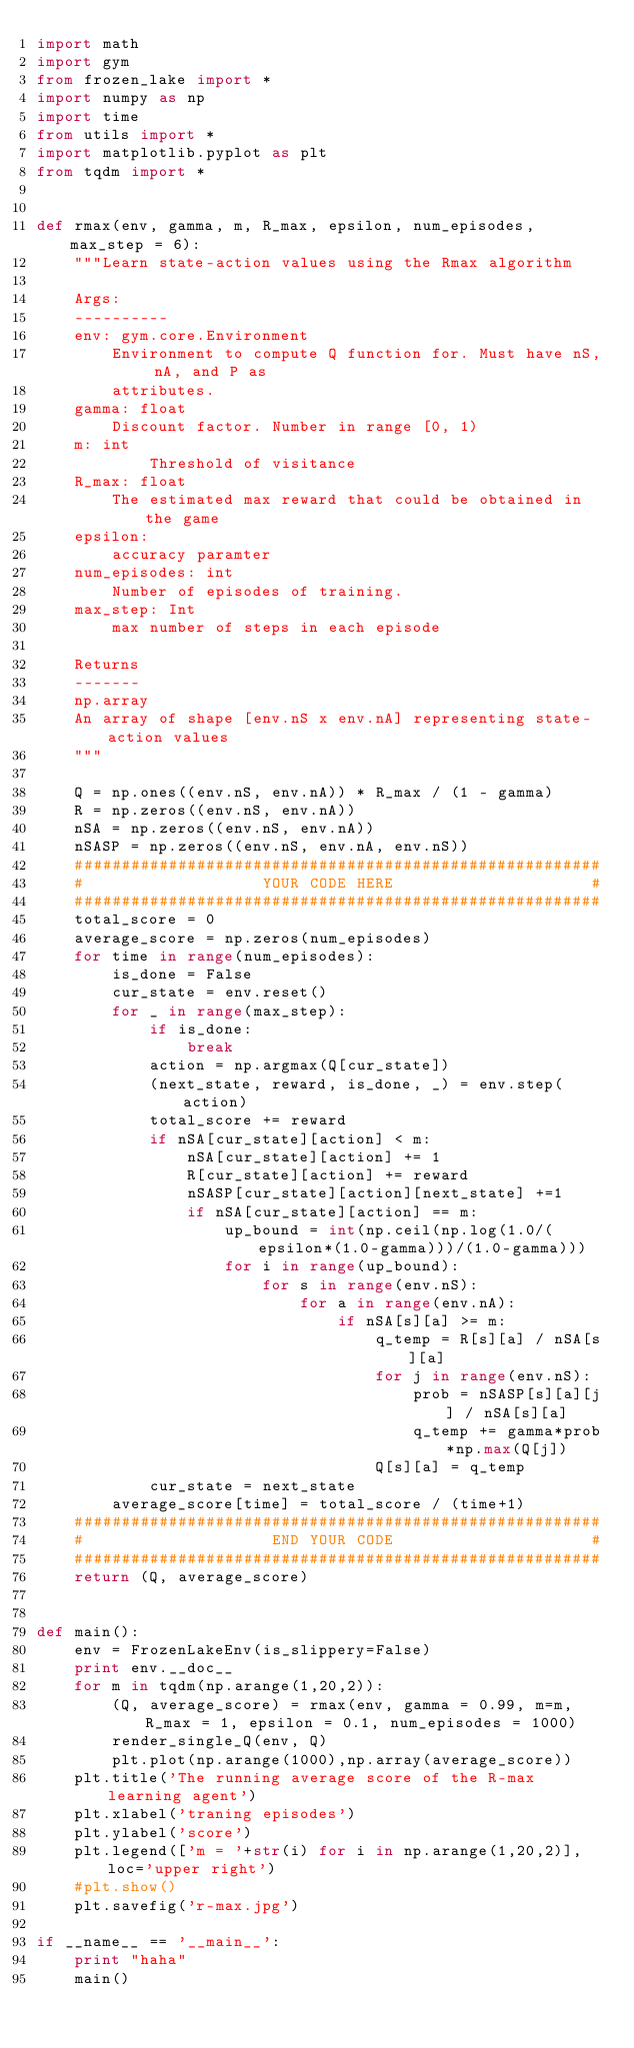<code> <loc_0><loc_0><loc_500><loc_500><_Python_>import math
import gym
from frozen_lake import *
import numpy as np
import time
from utils import *
import matplotlib.pyplot as plt
from tqdm import *


def rmax(env, gamma, m, R_max, epsilon, num_episodes, max_step = 6):
    """Learn state-action values using the Rmax algorithm

    Args:
    ----------
    env: gym.core.Environment
        Environment to compute Q function for. Must have nS, nA, and P as
        attributes.
    gamma: float
        Discount factor. Number in range [0, 1)
    m: int
        	Threshold of visitance
    R_max: float 
        The estimated max reward that could be obtained in the game
    epsilon: 
        accuracy paramter
    num_episodes: int 
        Number of episodes of training.
    max_step: Int
        max number of steps in each episode

    Returns
    -------
    np.array
    An array of shape [env.nS x env.nA] representing state-action values
    """

    Q = np.ones((env.nS, env.nA)) * R_max / (1 - gamma)
    R = np.zeros((env.nS, env.nA))
    nSA = np.zeros((env.nS, env.nA))
    nSASP = np.zeros((env.nS, env.nA, env.nS))
    ########################################################
    #                   YOUR CODE HERE                     #
    ########################################################
    total_score = 0
    average_score = np.zeros(num_episodes)
    for time in range(num_episodes):
        is_done = False
        cur_state = env.reset()
        for _ in range(max_step):
            if is_done:
                break
            action = np.argmax(Q[cur_state])
            (next_state, reward, is_done, _) = env.step(action)
            total_score += reward
            if nSA[cur_state][action] < m:
                nSA[cur_state][action] += 1
                R[cur_state][action] += reward
                nSASP[cur_state][action][next_state] +=1
                if nSA[cur_state][action] == m:
                    up_bound = int(np.ceil(np.log(1.0/(epsilon*(1.0-gamma)))/(1.0-gamma)))
                    for i in range(up_bound):
                        for s in range(env.nS):
                            for a in range(env.nA):
                                if nSA[s][a] >= m:
                                    q_temp = R[s][a] / nSA[s][a]
                                    for j in range(env.nS):
                                        prob = nSASP[s][a][j] / nSA[s][a]    
                                        q_temp += gamma*prob*np.max(Q[j])
                                    Q[s][a] = q_temp
            cur_state = next_state
        average_score[time] = total_score / (time+1)
    ########################################################
    #                    END YOUR CODE                     #
    ########################################################
    return (Q, average_score)


def main():
    env = FrozenLakeEnv(is_slippery=False)
    print env.__doc__
    for m in tqdm(np.arange(1,20,2)):
        (Q, average_score) = rmax(env, gamma = 0.99, m=m, R_max = 1, epsilon = 0.1, num_episodes = 1000)
        render_single_Q(env, Q)
        plt.plot(np.arange(1000),np.array(average_score))
    plt.title('The running average score of the R-max learning agent')
    plt.xlabel('traning episodes')
    plt.ylabel('score')
    plt.legend(['m = '+str(i) for i in np.arange(1,20,2)], loc='upper right')
    #plt.show()
    plt.savefig('r-max.jpg')

if __name__ == '__main__':
    print "haha"
    main()</code> 